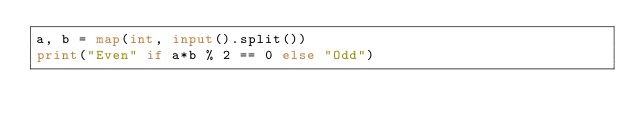<code> <loc_0><loc_0><loc_500><loc_500><_Python_>a, b = map(int, input().split())
print("Even" if a*b % 2 == 0 else "Odd")</code> 